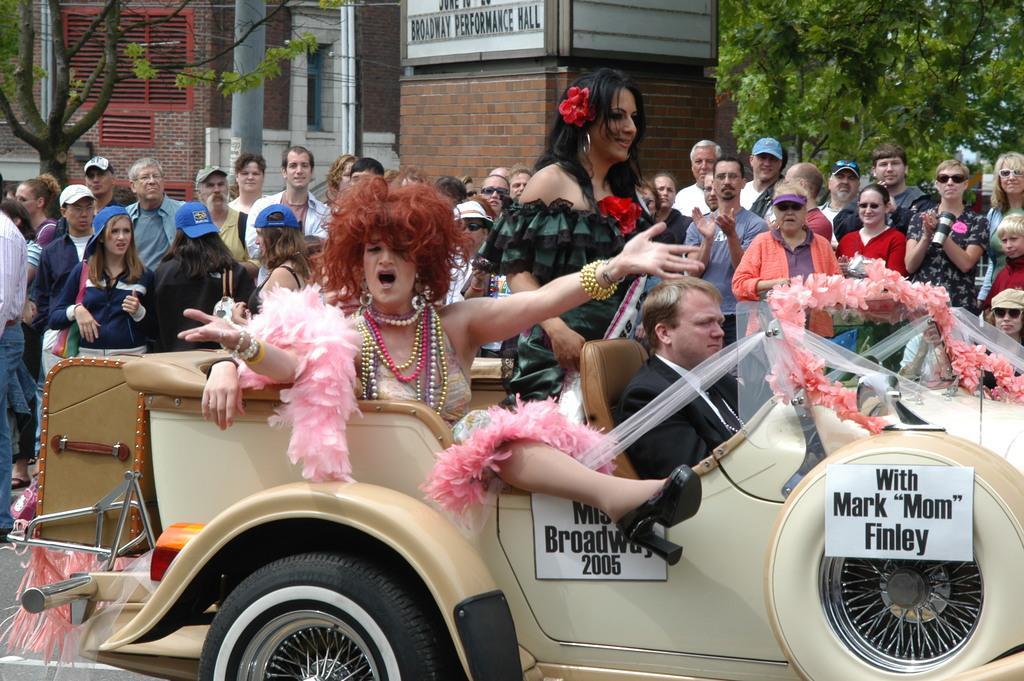Could you give a brief overview of what you see in this image? This image consists of some persons in the middle. There is a vehicle in the middle, in that there are some persons sitting. There are trees at the top. There are buildings at the top. 